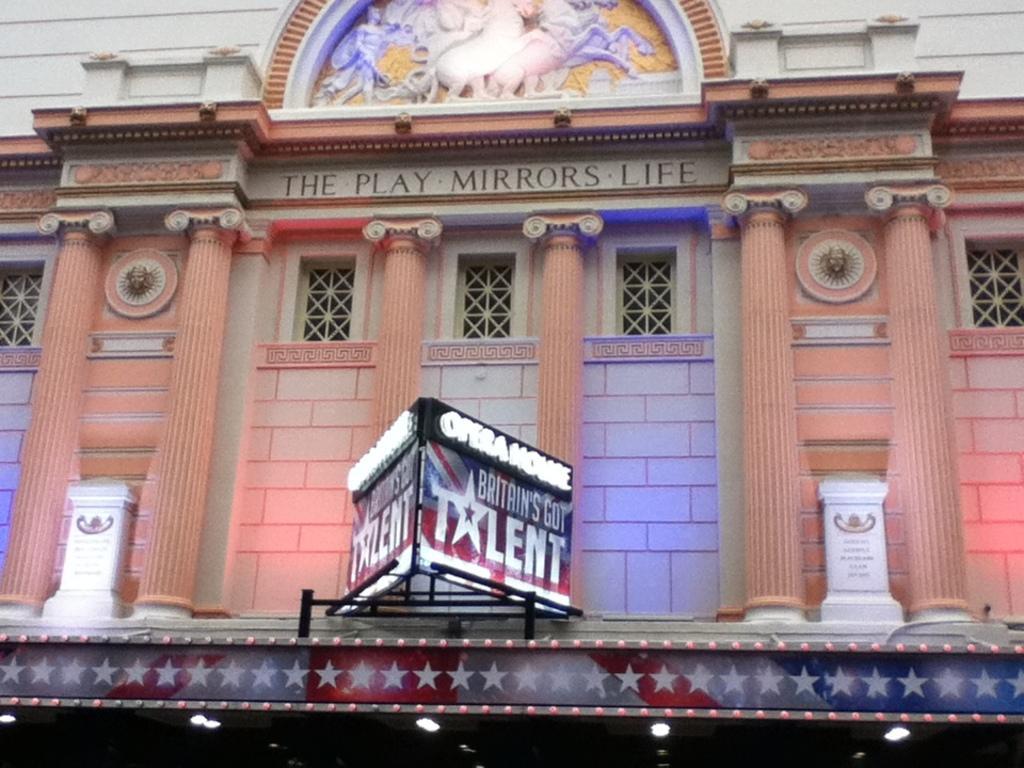In one or two sentences, can you explain what this image depicts? In this picture we can see a brown color building with a windows and pillars. In the front there is a advertising board. 